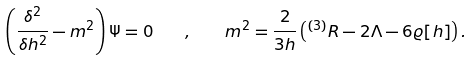Convert formula to latex. <formula><loc_0><loc_0><loc_500><loc_500>\left ( \frac { \delta ^ { 2 } } { \delta { h ^ { 2 } } } - m ^ { 2 } \right ) \Psi = 0 \quad , \quad m ^ { 2 } = \frac { 2 } { 3 h } \left ( { ^ { ( 3 ) } } R - 2 \Lambda - 6 \varrho [ h ] \right ) .</formula> 